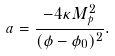Convert formula to latex. <formula><loc_0><loc_0><loc_500><loc_500>a = \frac { - 4 \kappa M _ { p } ^ { 2 } } { ( \phi - \phi _ { 0 } ) ^ { 2 } } .</formula> 